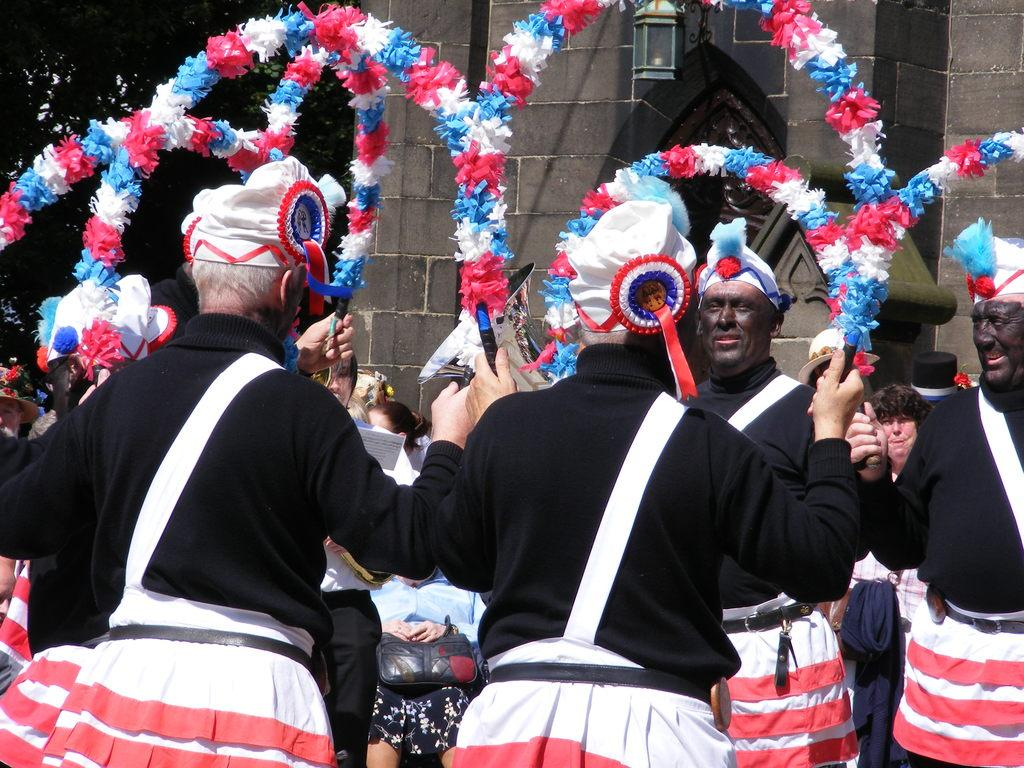How many people are in the image? There is a group of people in the image, but the exact number is not specified. What are the people doing in the image? The people are performing different actions in the image. What color are the coats worn by the people? The people are wearing black coats in the image. What color are the shorts worn by the people? The people are wearing white and red shorts in the image. What can be seen in the middle of the image? There is a stone wall in the middle of the image. What type of apparel is being blown away by the wind in the image? There is no apparel being blown away by the wind in the image. What rule is being enforced by the people in the image? There is no indication of a rule being enforced by the people in the image. 